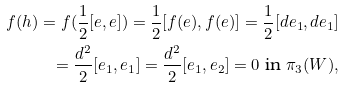Convert formula to latex. <formula><loc_0><loc_0><loc_500><loc_500>f ( h ) = f ( \frac { 1 } { 2 } [ e , e ] ) = \frac { 1 } { 2 } [ f ( e ) , f ( e ) ] = \frac { 1 } { 2 } [ d e _ { 1 } , d e _ { 1 } ] \\ = \frac { d ^ { 2 } } { 2 } [ e _ { 1 } , e _ { 1 } ] = \frac { d ^ { 2 } } { 2 } [ e _ { 1 } , e _ { 2 } ] = 0 \text {\ in\ } \pi _ { 3 } ( W ) ,</formula> 